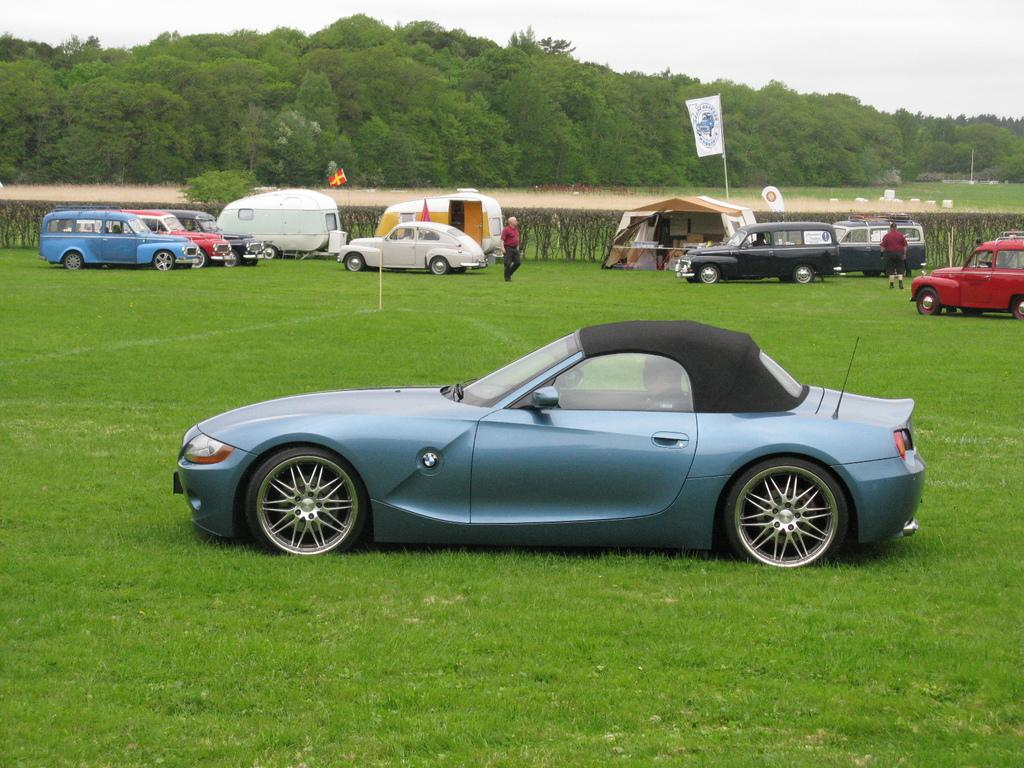What is the primary surface visible in the image? There is a ground in the image. What can be seen on the ground in the image? Different types of vehicles are parked on the ground. What type of natural environment surrounds the ground? There are plenty of trees around the ground. What type of apparel is the boy wearing while sitting on the seat in the image? There is no boy or seat present in the image; it only features a ground with parked vehicles and trees. 